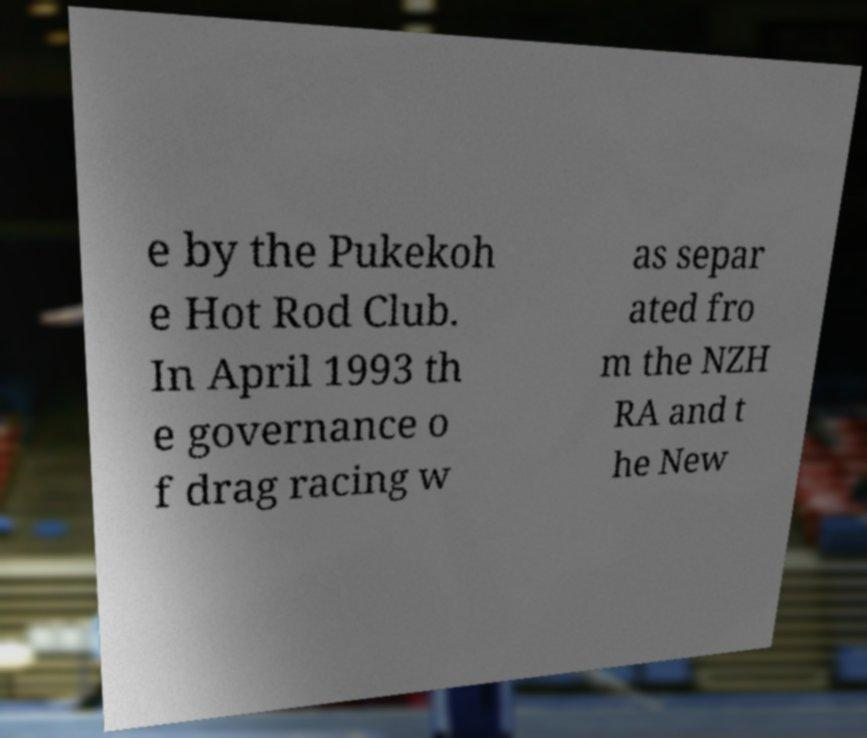What messages or text are displayed in this image? I need them in a readable, typed format. e by the Pukekoh e Hot Rod Club. In April 1993 th e governance o f drag racing w as separ ated fro m the NZH RA and t he New 